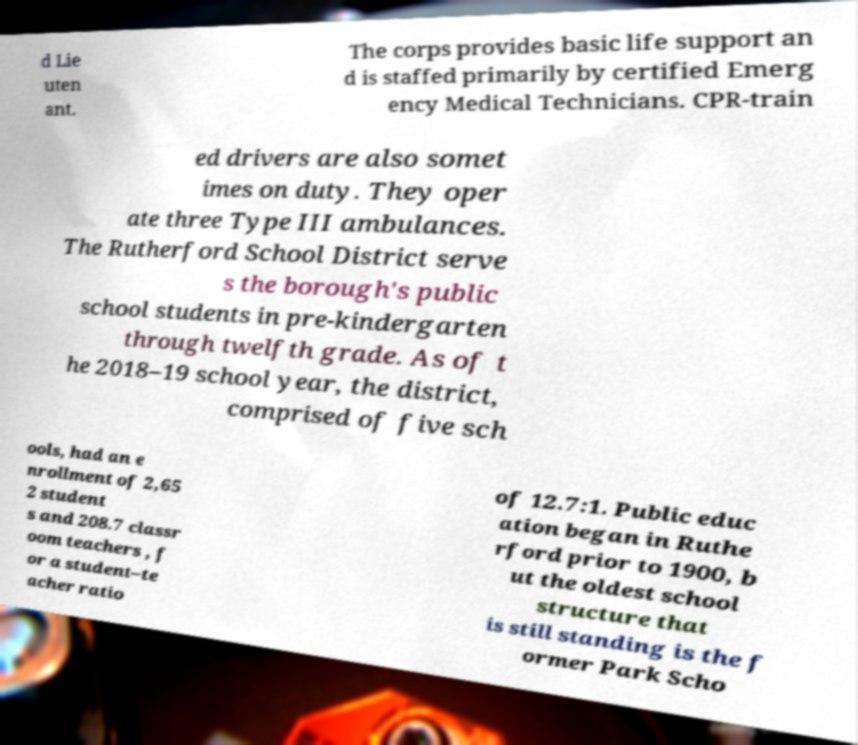Please read and relay the text visible in this image. What does it say? d Lie uten ant. The corps provides basic life support an d is staffed primarily by certified Emerg ency Medical Technicians. CPR-train ed drivers are also somet imes on duty. They oper ate three Type III ambulances. The Rutherford School District serve s the borough's public school students in pre-kindergarten through twelfth grade. As of t he 2018–19 school year, the district, comprised of five sch ools, had an e nrollment of 2,65 2 student s and 208.7 classr oom teachers , f or a student–te acher ratio of 12.7:1. Public educ ation began in Ruthe rford prior to 1900, b ut the oldest school structure that is still standing is the f ormer Park Scho 